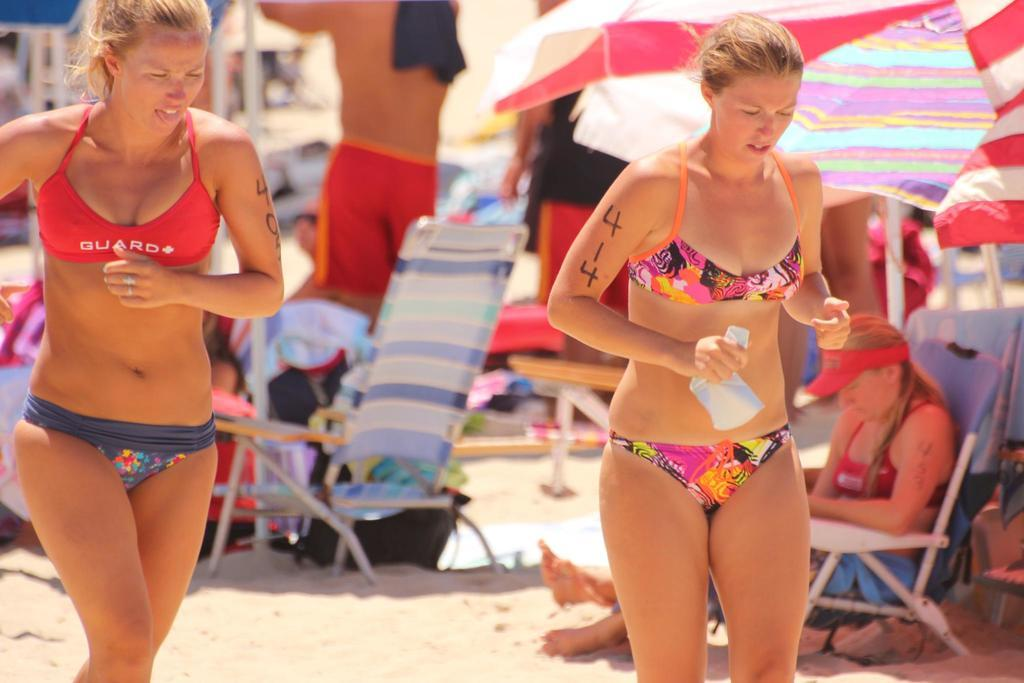How many girls are in the image? There are two girls in the image, one on the right side and one on the left side. What can be seen in the background of the image? There are other people in the background of the image. What are the people in the background doing? The people in the background are under umbrellas. What type of faucet can be seen in the image? There is no faucet present in the image. What song are the girls singing in the image? The image does not provide any information about the girls singing a song. 